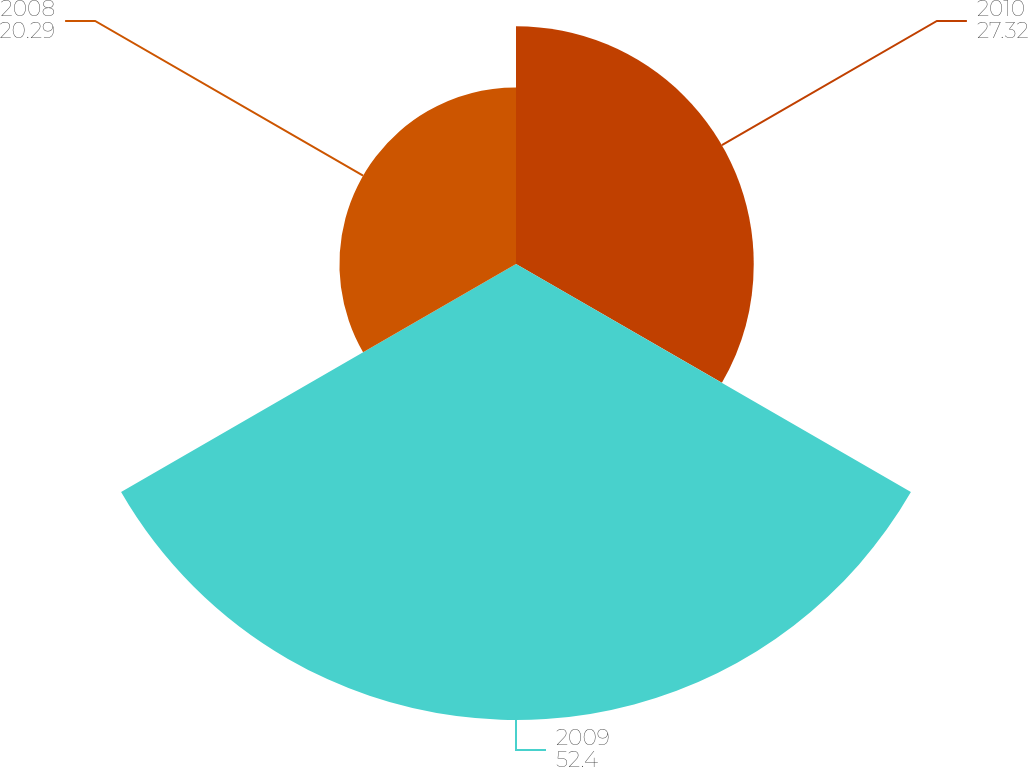<chart> <loc_0><loc_0><loc_500><loc_500><pie_chart><fcel>2010<fcel>2009<fcel>2008<nl><fcel>27.32%<fcel>52.4%<fcel>20.29%<nl></chart> 